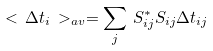Convert formula to latex. <formula><loc_0><loc_0><loc_500><loc_500>< \, \Delta t _ { i } \, > _ { a v } = \sum _ { j } \, S _ { i j } ^ { * } S _ { i j } \Delta t _ { i j }</formula> 